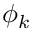<formula> <loc_0><loc_0><loc_500><loc_500>\phi _ { k }</formula> 